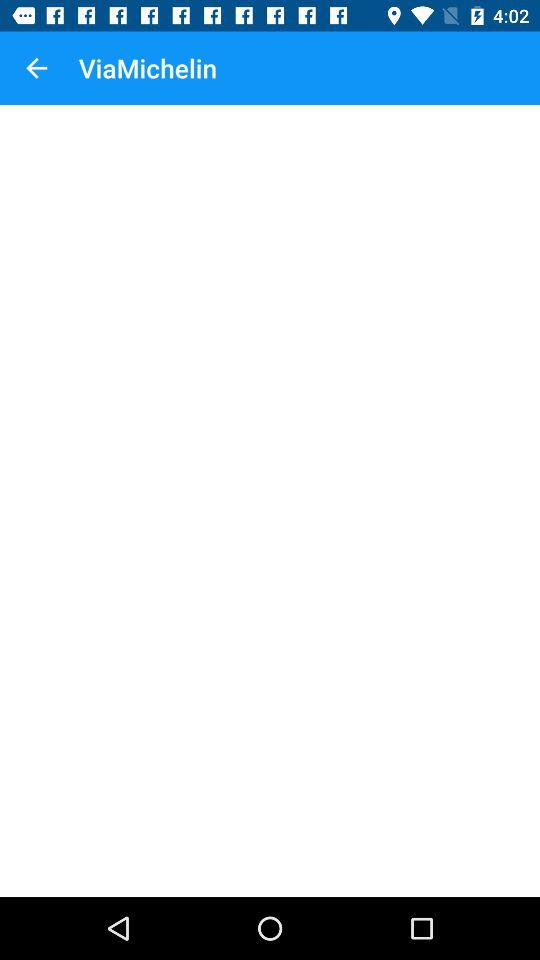Who developed the "ViaMichelin" app?
When the provided information is insufficient, respond with <no answer>. <no answer> 